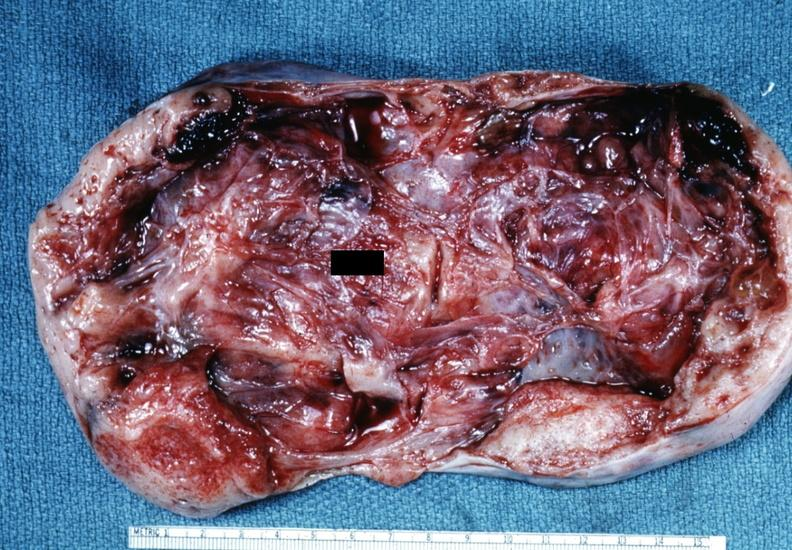what is not diagnostic?
Answer the question using a single word or phrase. This partially fixed gross 